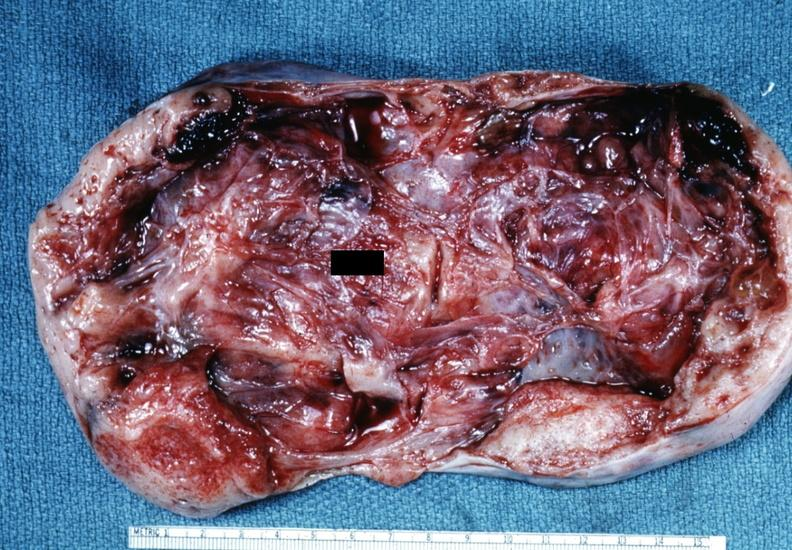what is not diagnostic?
Answer the question using a single word or phrase. This partially fixed gross 